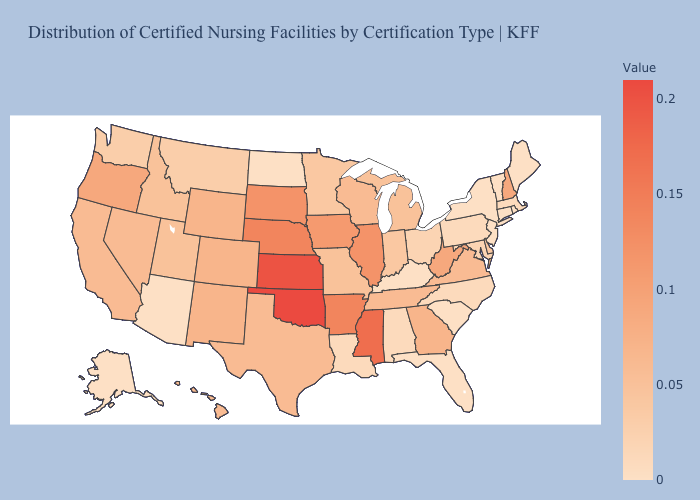Which states have the lowest value in the MidWest?
Keep it brief. North Dakota. Among the states that border Colorado , does Wyoming have the lowest value?
Concise answer only. No. Does Missouri have the highest value in the USA?
Answer briefly. No. Does Nevada have a lower value than Louisiana?
Keep it brief. No. Does Virginia have a lower value than Maryland?
Answer briefly. No. 